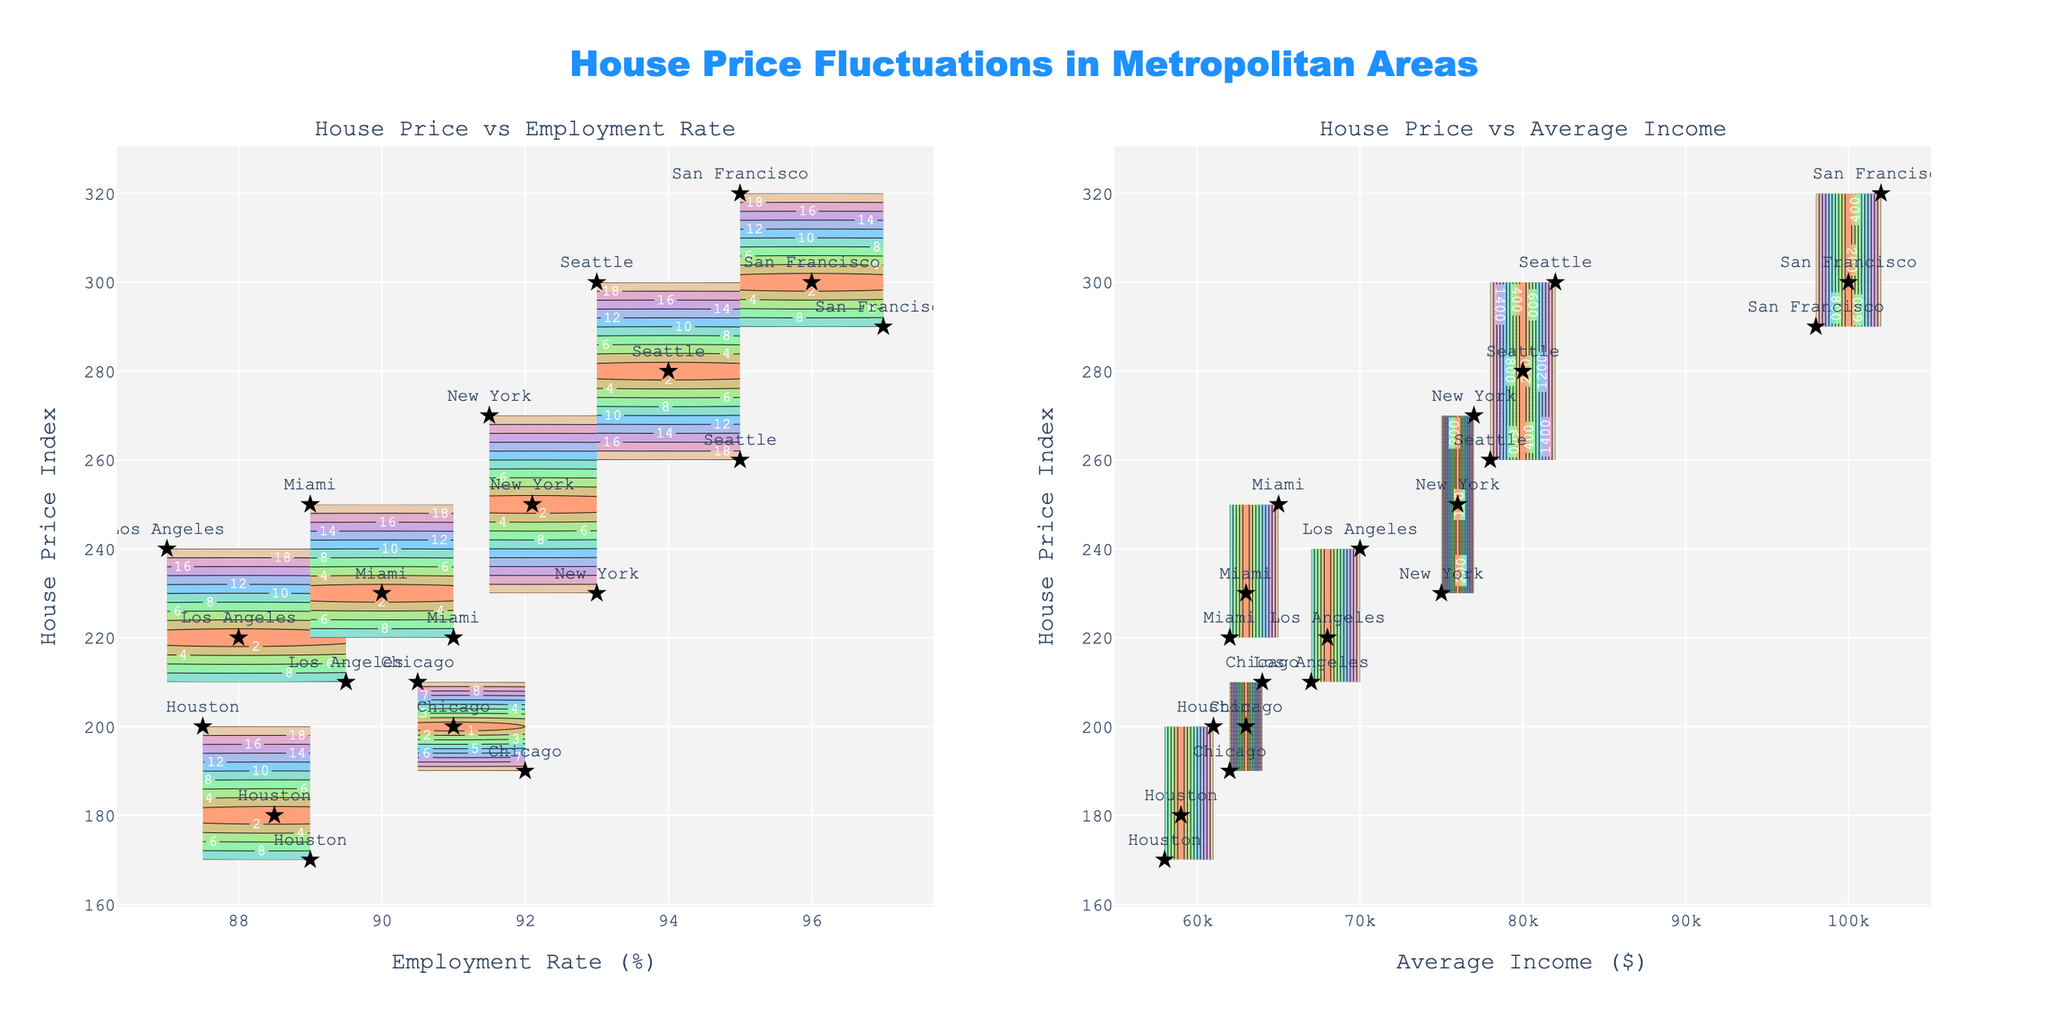What's the title of the figure? The title is positioned at the top center of the figure. It reads "House Price Fluctuations in Metropolitan Areas."
Answer: House Price Fluctuations in Metropolitan Areas What are the two subplots in the figure? The subplot titles can be found at the top of each subplot. The left subplot is titled 'House Price vs Employment Rate,' and the right subplot is titled 'House Price vs Average Income.'
Answer: House Price vs Employment Rate (left) and House Price vs Average Income (right) Which metropolitan area appears in the top-right corner of both subplots? In the top-right corner of both subplots, the scatter plot markers for New York stand out due to their high employment rate, average income, and consistent house price index relative to other areas.
Answer: New York Which metropolitan area has the highest house price index on the left subplot (House Price vs Employment Rate)? On the left subplot, the contour and scatter plot markers indicate that the highest house price index is located in San Francisco, with a value around or above 300.
Answer: San Francisco What is the range of average income shown in the right subplot? The x-axis of the right subplot represents average income, which ranges from $58,000 to $102,000 as indicated by the tick labels.
Answer: $58,000 to $102,000 Which metropolitan areas have a house price index above 250 on both subplots? By analyzing the contour and scatter plots, both New York and San Francisco have several data points with a house price index above 250 on both subplots.
Answer: New York and San Francisco How do the house price indices of Houston and Miami compare on the left subplot? On the left subplot, Miami’s house price index ranges around 220-250, while Houston’s house price index is lower, ranging from 170-200, indicating that Miami generally has a higher house price index than Houston.
Answer: Miami has a higher house price index than Houston What is the relationship between Seattle's average income and house price index on the right subplot? The scatter plot markers on the right subplot for Seattle show that as average income increases from around $78,000 to $82,000, the house price index increases from 260 to 300. There is a positive correlation between average income and house price index for Seattle.
Answer: Positive correlation Which metropolitan area shows the largest variation in house price index? Based on the scatter plot markers in both subplots, New York shows the largest variation in house price index, ranging from 230 to 270, indicating a volatile housing market.
Answer: New York What color scale is used for the contour plots? The contour plots use a custom color scale that includes shades of light red (#FFA07A), light green (#98FB98), light blue (#87CEFA), light purple (#DDA0DD), and light yellow (#F0E68C).
Answer: Custom color scale with light red, green, blue, purple, and yellow 